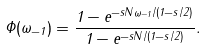Convert formula to latex. <formula><loc_0><loc_0><loc_500><loc_500>\Phi ( \omega _ { - 1 } ) = \frac { 1 - e ^ { - s N \omega _ { - 1 } / ( 1 - s / 2 ) } } { 1 - e ^ { - s N / ( 1 - s / 2 ) } } .</formula> 